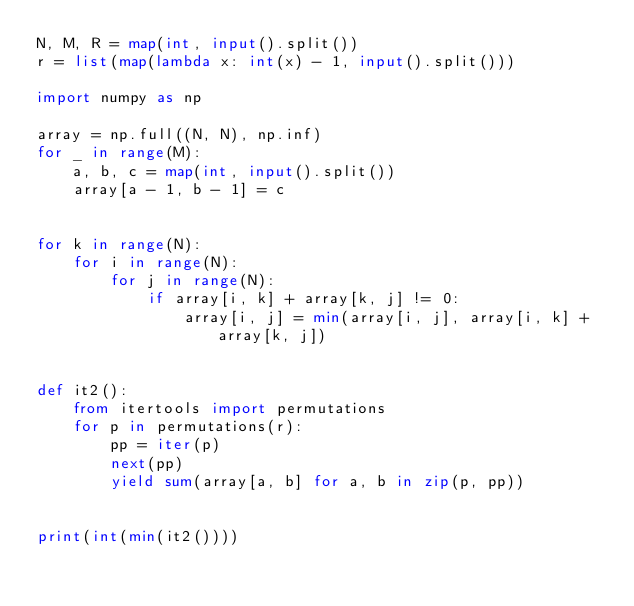Convert code to text. <code><loc_0><loc_0><loc_500><loc_500><_Python_>N, M, R = map(int, input().split())
r = list(map(lambda x: int(x) - 1, input().split()))

import numpy as np

array = np.full((N, N), np.inf)
for _ in range(M):
    a, b, c = map(int, input().split())
    array[a - 1, b - 1] = c


for k in range(N):
    for i in range(N):
        for j in range(N):
            if array[i, k] + array[k, j] != 0:
                array[i, j] = min(array[i, j], array[i, k] + array[k, j])


def it2():
    from itertools import permutations
    for p in permutations(r):
        pp = iter(p)
        next(pp)
        yield sum(array[a, b] for a, b in zip(p, pp))


print(int(min(it2())))</code> 